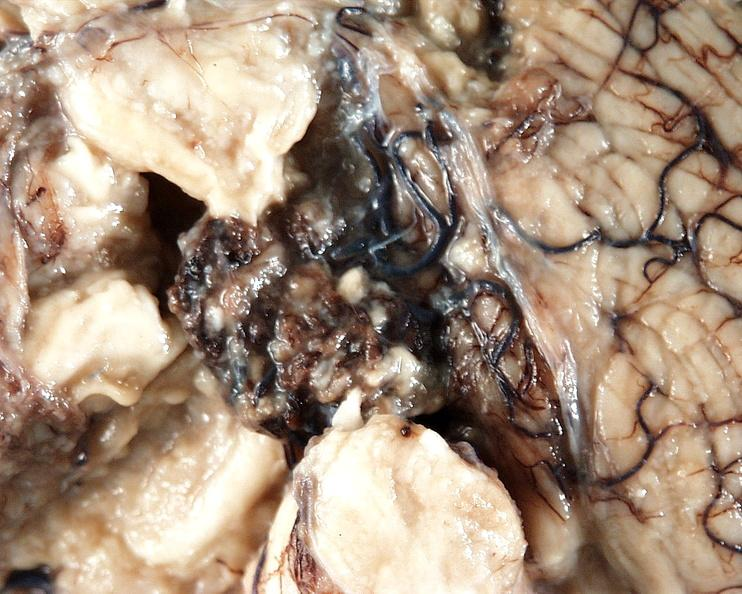s nervous present?
Answer the question using a single word or phrase. Yes 